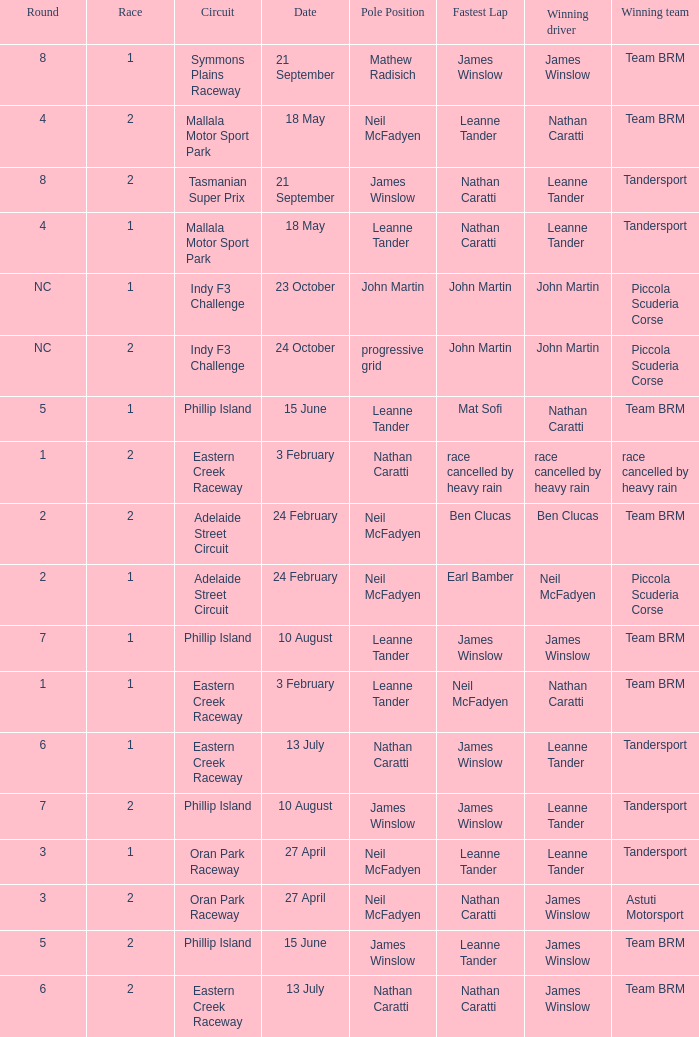What is the highest race number in the Phillip Island circuit with James Winslow as the winning driver and pole position? 2.0. 